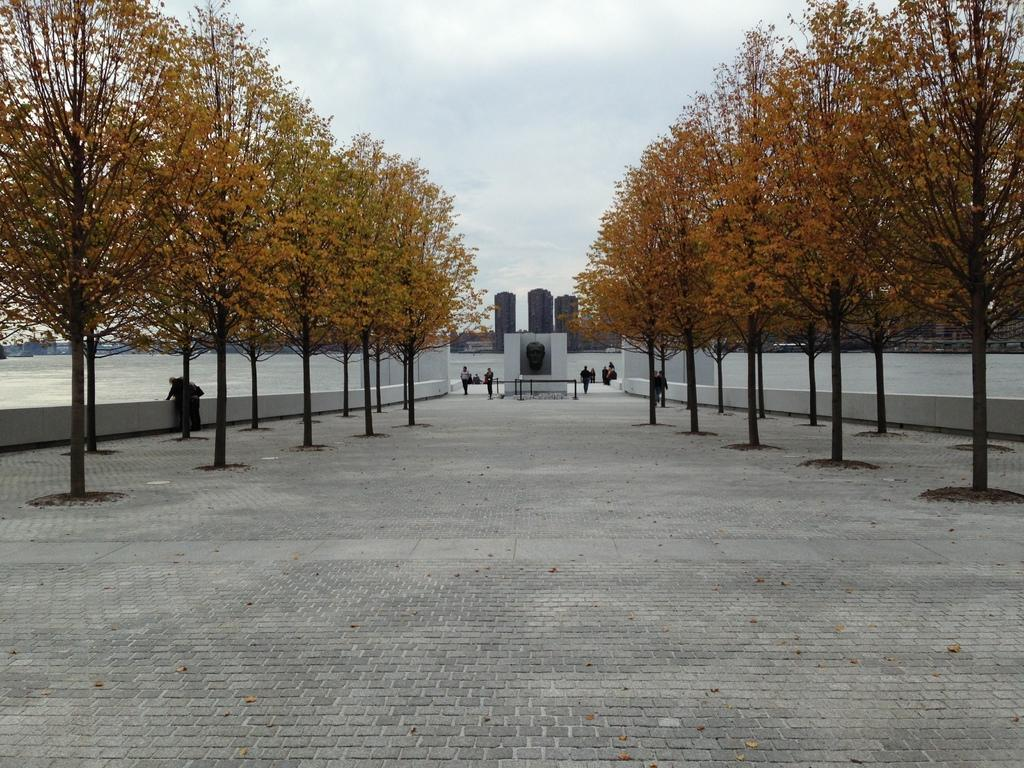How many people are in the image? There is a group of people in the image, but the exact number is not specified. What are the people in the image doing? Some people are standing, while others are walking. What can be seen on the ground in the image? The ground is visible in the image. What type of vegetation is present in the image? There are trees in the image. What natural element is present in the image? There is water in the image. What type of structures can be seen in the image? There are buildings in the image. What is visible in the background of the image? The sky is visible in the background of the image. What can be seen in the sky in the image? Clouds are present in the sky. What type of monkey can be seen learning to play the flesh in the image? There is no monkey or flesh present in the image. 